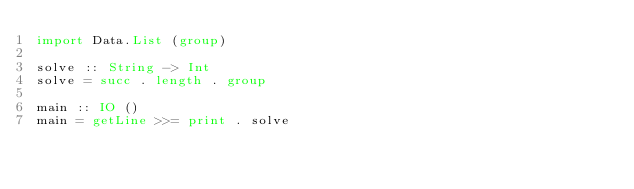Convert code to text. <code><loc_0><loc_0><loc_500><loc_500><_Haskell_>import Data.List (group)

solve :: String -> Int
solve = succ . length . group

main :: IO ()
main = getLine >>= print . solve
</code> 